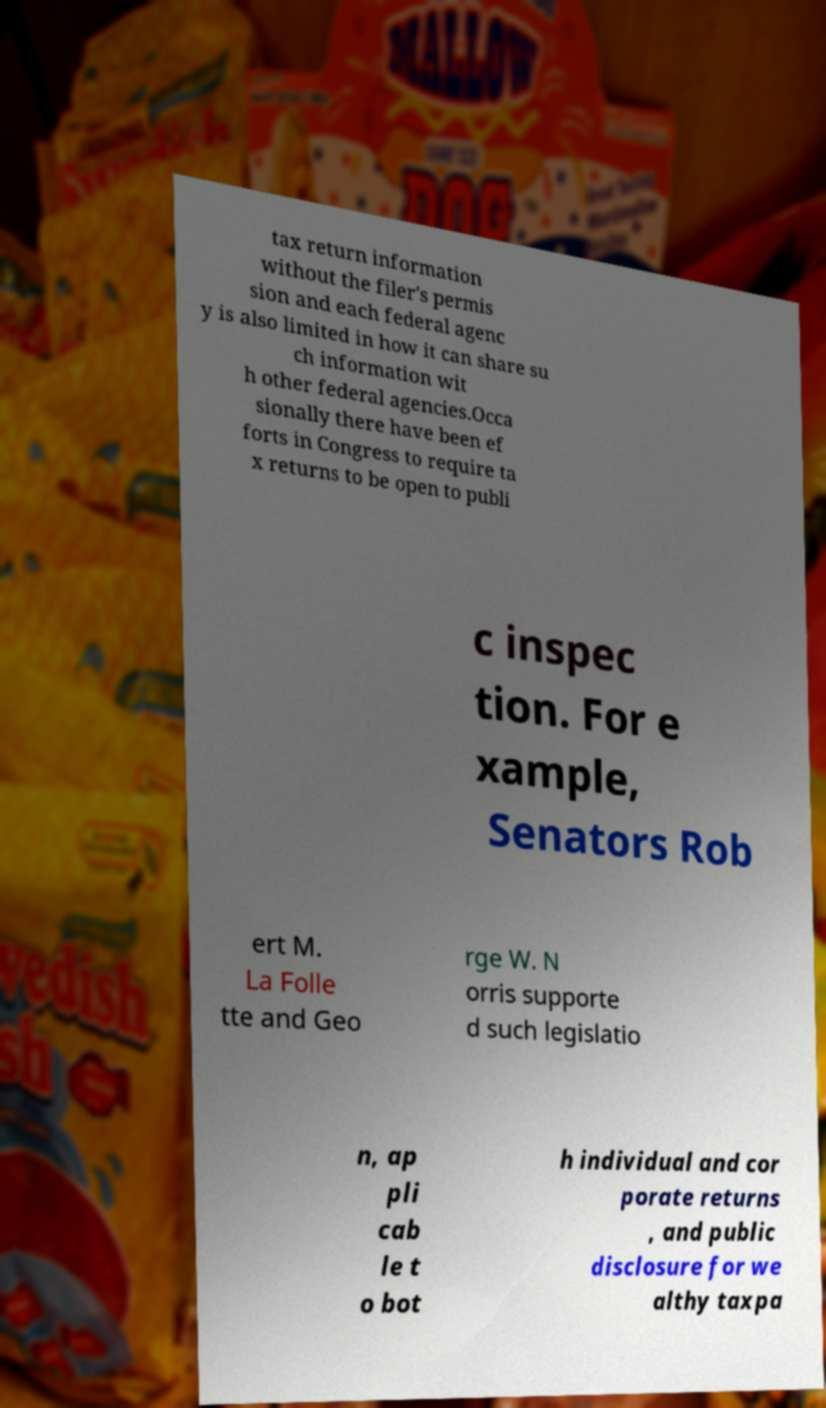What messages or text are displayed in this image? I need them in a readable, typed format. tax return information without the filer's permis sion and each federal agenc y is also limited in how it can share su ch information wit h other federal agencies.Occa sionally there have been ef forts in Congress to require ta x returns to be open to publi c inspec tion. For e xample, Senators Rob ert M. La Folle tte and Geo rge W. N orris supporte d such legislatio n, ap pli cab le t o bot h individual and cor porate returns , and public disclosure for we althy taxpa 